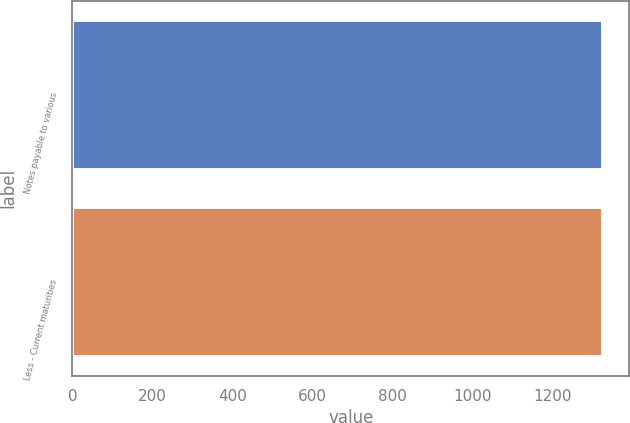<chart> <loc_0><loc_0><loc_500><loc_500><bar_chart><fcel>Notes payable to various<fcel>Less - Current maturities<nl><fcel>1327<fcel>1327.1<nl></chart> 